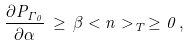Convert formula to latex. <formula><loc_0><loc_0><loc_500><loc_500>\frac { \partial P _ { \Gamma _ { 0 } } } { \partial \alpha } \, \geq \, \beta < n > _ { T } \, \geq 0 \, ,</formula> 